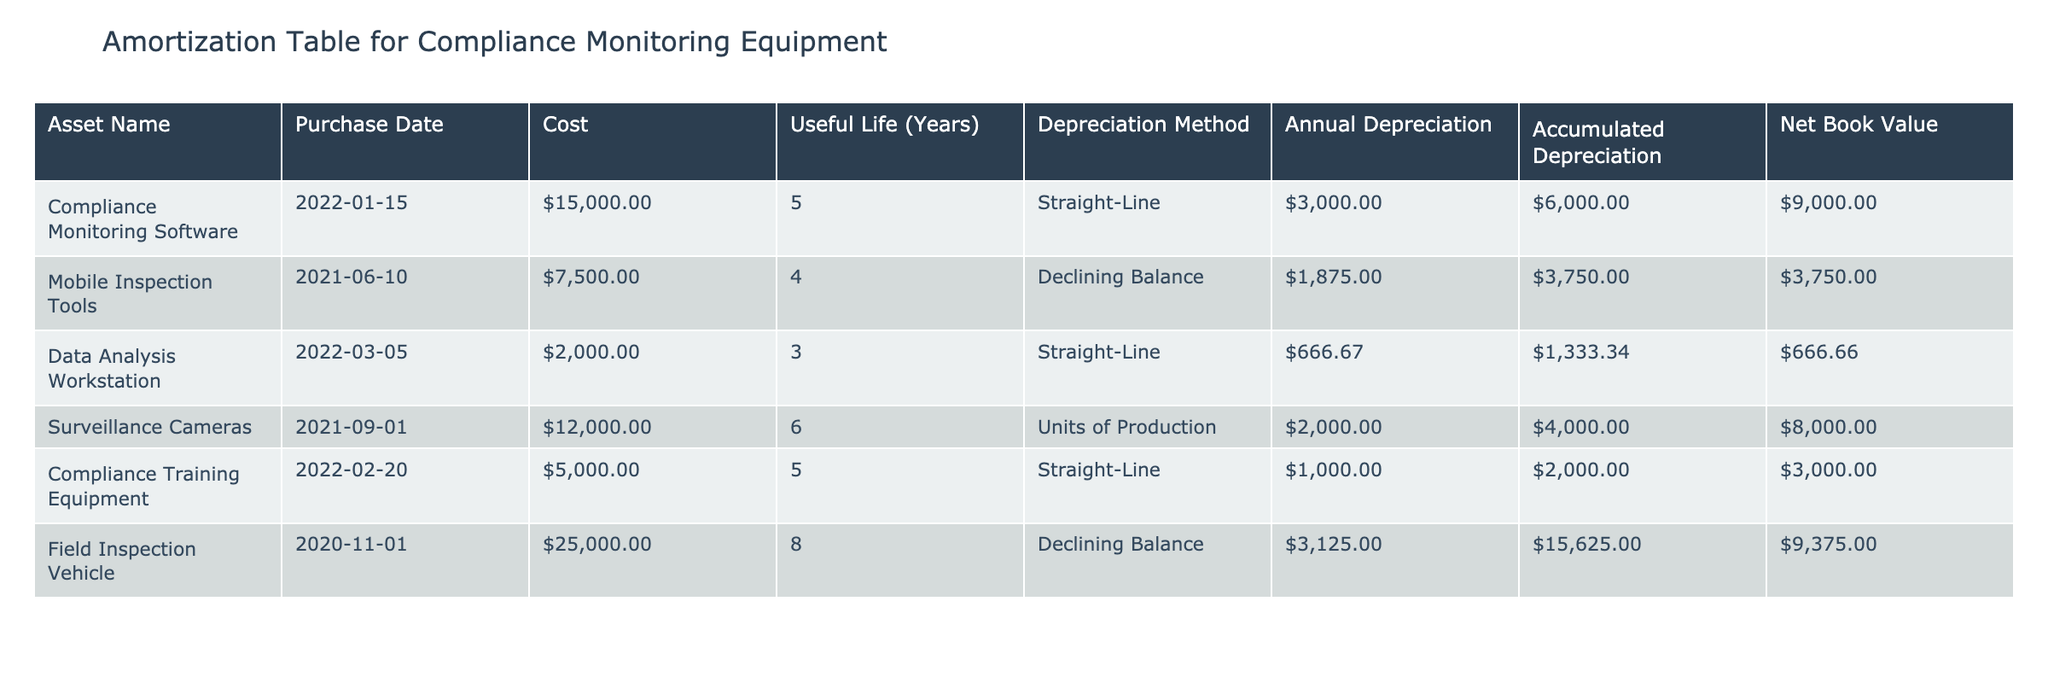What is the annual depreciation for the Data Analysis Workstation? The annual depreciation for the Data Analysis Workstation is listed in the "Annual Depreciation" column under its row, which shows a value of $666.67.
Answer: $666.67 What is the total accumulated depreciation for all equipment? To find the total accumulated depreciation, we sum the "Accumulated Depreciation" values: $6000 + $3750 + $1333.34 + $4000 + $2000 + $15625 = $26808.34.
Answer: $26808.34 Is the Net Book Value of the Mobile Inspection Tools greater than $2000? The Net Book Value for the Mobile Inspection Tools is $3750, which is indeed greater than $2000.
Answer: Yes What is the difference in cost between the most expensive and the least expensive asset? The most expensive asset is the Field Inspection Vehicle at $25000, while the least expensive asset is the Data Analysis Workstation at $2000. Therefore, the difference is $25000 - $2000 = $23000.
Answer: $23000 Which asset has the highest accumulated depreciation? By comparing the "Accumulated Depreciation" values, the Field Inspection Vehicle has the highest accumulated depreciation at $15625.
Answer: Field Inspection Vehicle What is the average annual depreciation of all assets? First, we sum the annual depreciation values: $3000 + $1875 + $666.67 + $2000 + $1000 + $3125 = $11666.67. Then, we divide this sum by the number of assets, which is 6: $11666.67 / 6 = $1944.44.
Answer: $1944.44 Is the useful life of the Compliance Monitoring Software equal to that of the Compliance Training Equipment? The Compliance Monitoring Software has a useful life of 5 years and the Compliance Training Equipment also has a useful life of 5 years. Therefore, they are equal.
Answer: Yes What is the net book value of the Surveillance Cameras? The net book value for the Surveillance Cameras is shown in the "Net Book Value" column, which is $8000.
Answer: $8000 How many assets are subject to the Straight-Line depreciation method? There are three assets that use the Straight-Line depreciation method: Compliance Monitoring Software, Data Analysis Workstation, and Compliance Training Equipment.
Answer: 3 